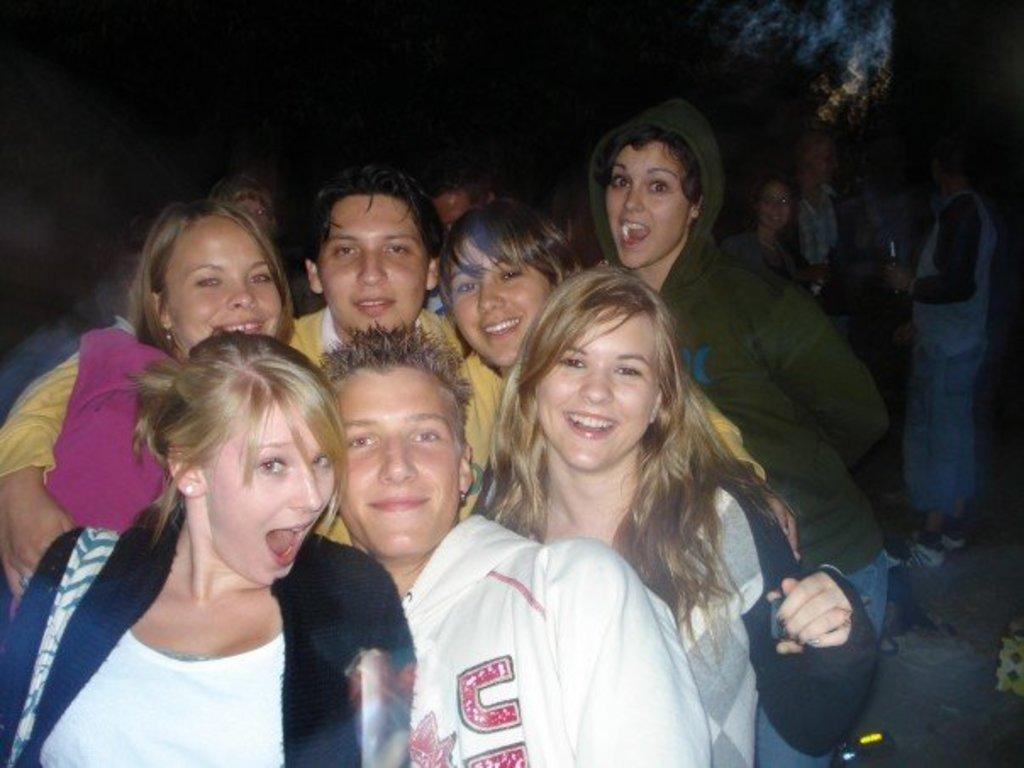What is the main subject of the image? The main subject of the image is a group of people. What are the people in the image doing? The people are posing for the camera. What expressions do the people have on their faces? The people have smiles on their faces. What type of queen can be seen in the image? There is no queen present in the image; it features a group of people posing for the camera. How many ladybugs are visible on the people's clothing in the image? There are no ladybugs visible on the people's clothing in the image. 